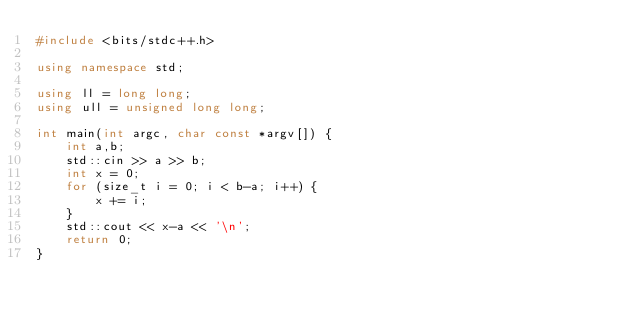<code> <loc_0><loc_0><loc_500><loc_500><_C++_>#include <bits/stdc++.h>

using namespace std;

using ll = long long;
using ull = unsigned long long;

int main(int argc, char const *argv[]) {
	int a,b;
	std::cin >> a >> b;
	int x = 0;
	for (size_t i = 0; i < b-a; i++) {
		x += i;
	}
	std::cout << x-a << '\n';
	return 0;
}
</code> 